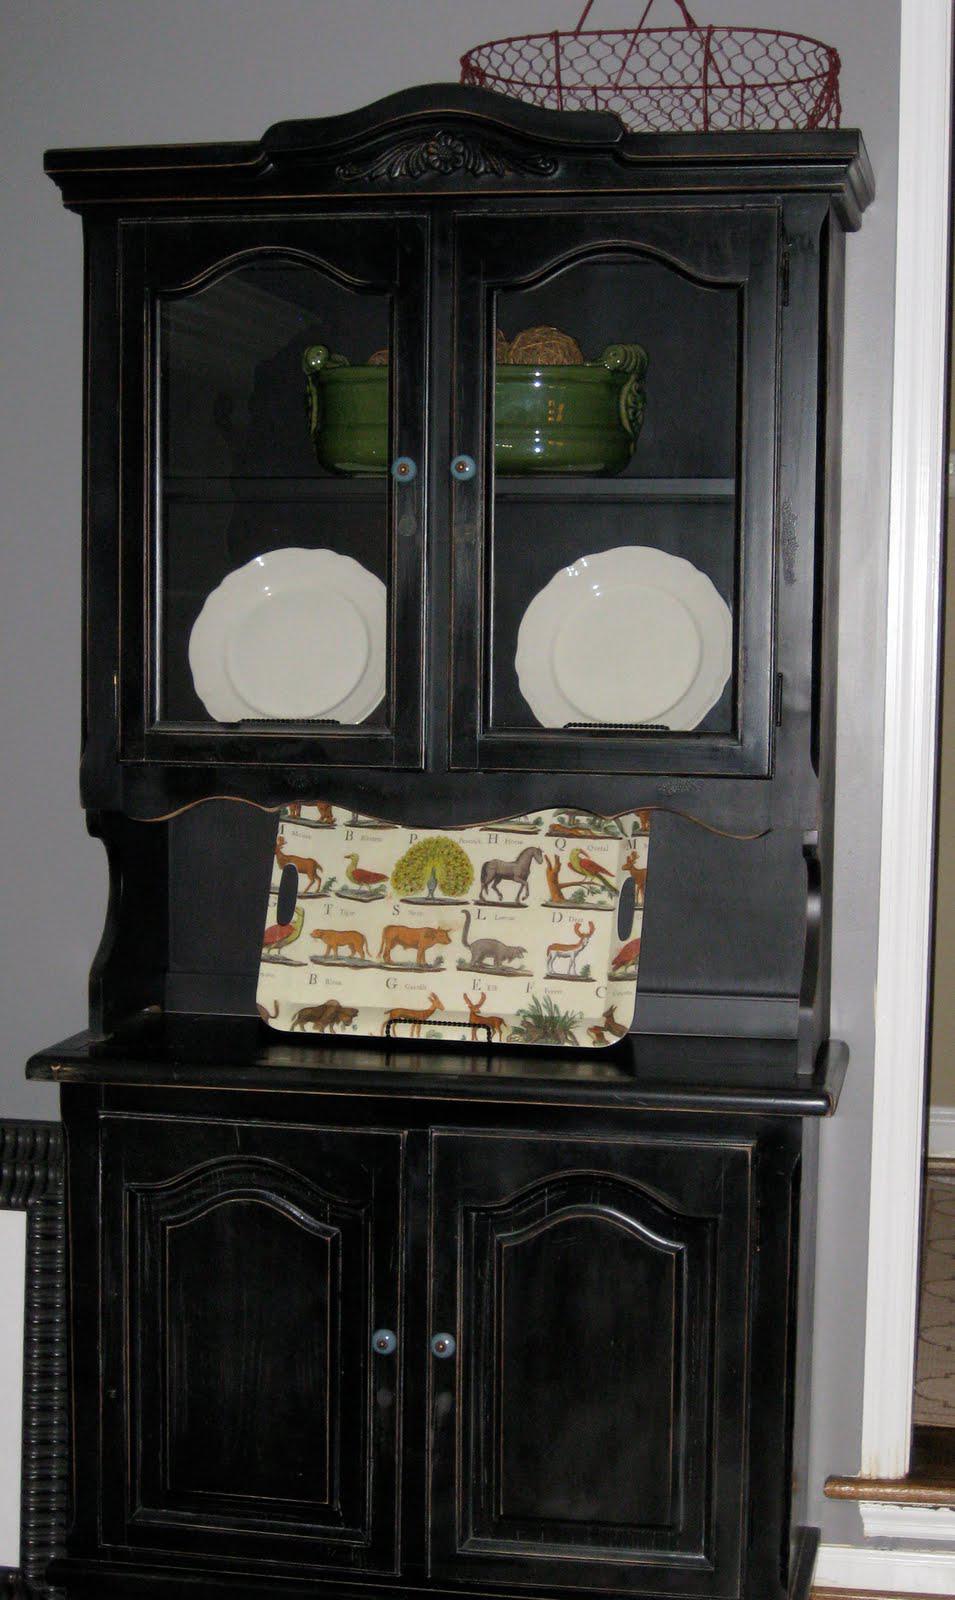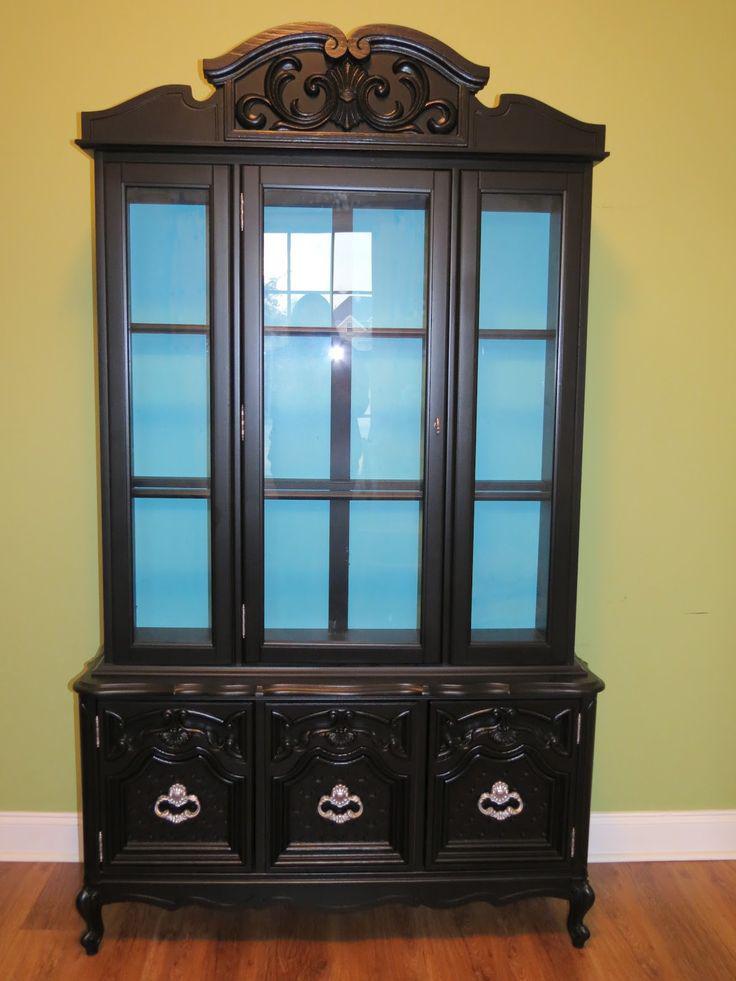The first image is the image on the left, the second image is the image on the right. Given the left and right images, does the statement "There is at least one item on top of the cabinet in the image on the left." hold true? Answer yes or no. Yes. 